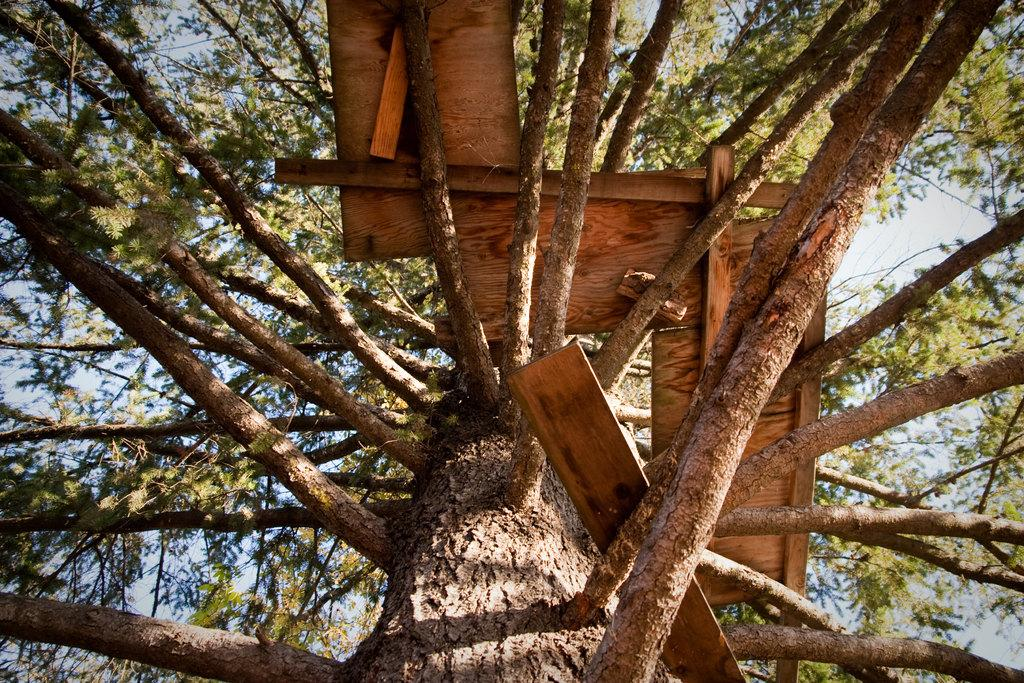What is the main subject of the image? The main subject of the image is a tree. Can you describe the tree in the image? There is a tree in the center of the image. Are there any additional objects or features on the tree? Yes, there are wooden boards on the tree. What type of apparatus is attached to the tree for climbing in the image? There is no apparatus for climbing present on the tree in the image. How many eggs are visible on the tree in the image? There are no eggs visible on the tree in the image. 